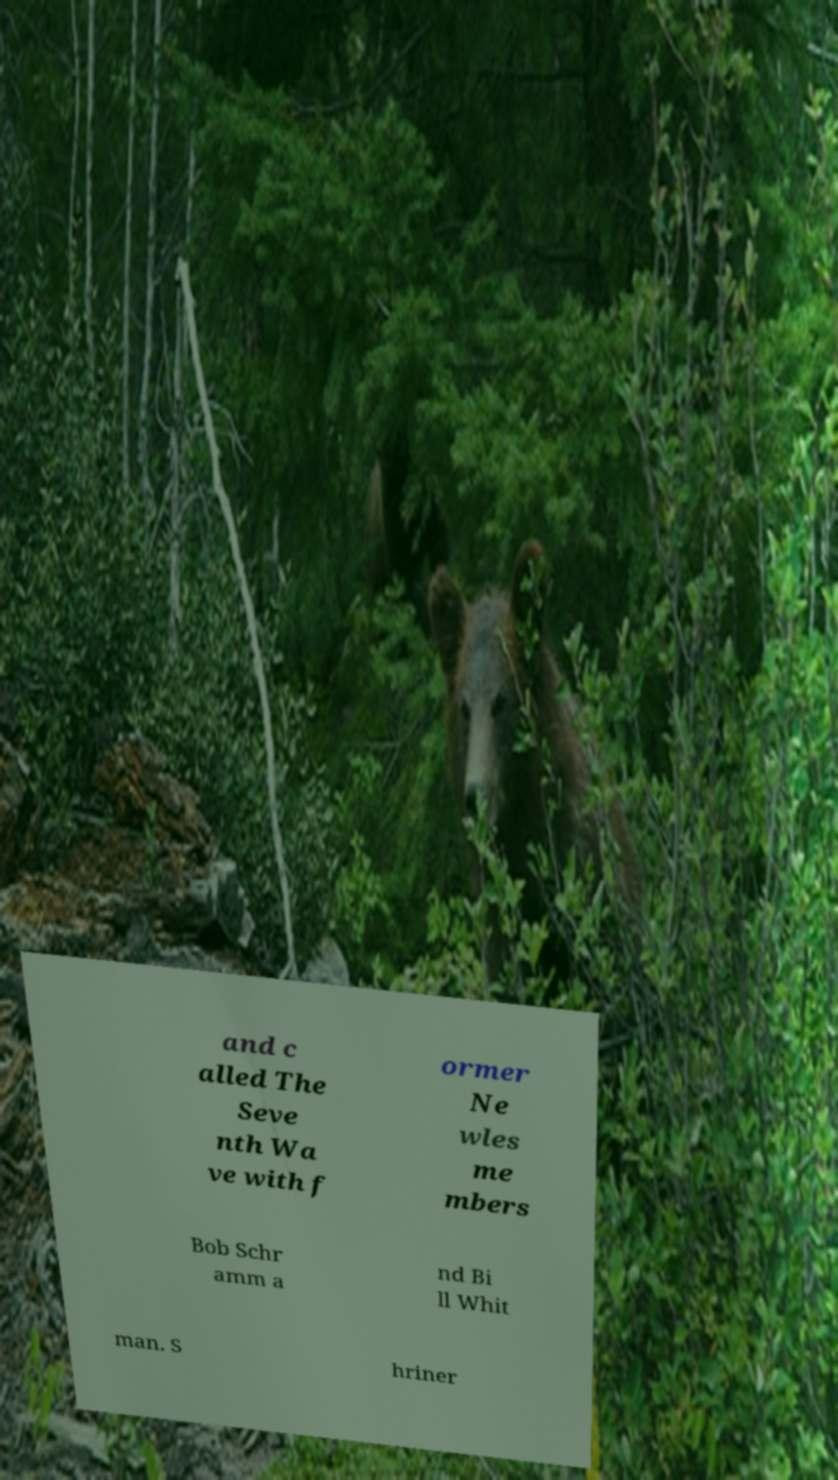Could you assist in decoding the text presented in this image and type it out clearly? and c alled The Seve nth Wa ve with f ormer Ne wles me mbers Bob Schr amm a nd Bi ll Whit man. S hriner 